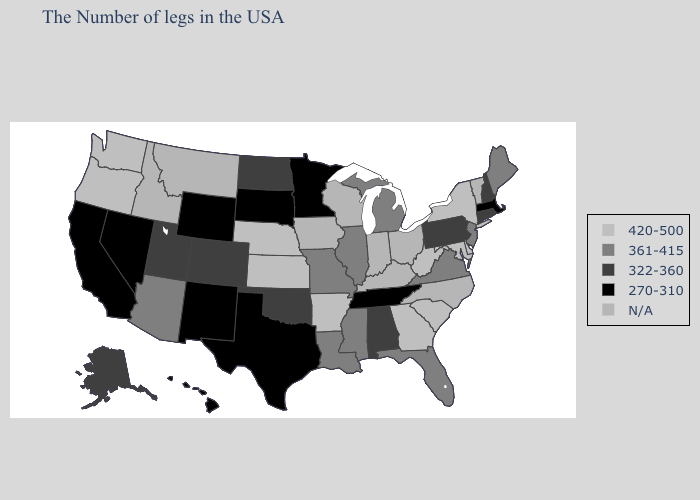Name the states that have a value in the range 420-500?
Answer briefly. New York, Delaware, Maryland, South Carolina, West Virginia, Georgia, Arkansas, Kansas, Nebraska, Washington, Oregon. Name the states that have a value in the range 420-500?
Answer briefly. New York, Delaware, Maryland, South Carolina, West Virginia, Georgia, Arkansas, Kansas, Nebraska, Washington, Oregon. Which states have the lowest value in the USA?
Give a very brief answer. Massachusetts, Tennessee, Minnesota, Texas, South Dakota, Wyoming, New Mexico, Nevada, California, Hawaii. Does Louisiana have the highest value in the South?
Keep it brief. No. What is the highest value in the MidWest ?
Write a very short answer. 420-500. What is the value of South Dakota?
Concise answer only. 270-310. Among the states that border New Hampshire , does Massachusetts have the highest value?
Short answer required. No. What is the value of Kentucky?
Short answer required. N/A. Which states have the lowest value in the USA?
Give a very brief answer. Massachusetts, Tennessee, Minnesota, Texas, South Dakota, Wyoming, New Mexico, Nevada, California, Hawaii. Name the states that have a value in the range 420-500?
Concise answer only. New York, Delaware, Maryland, South Carolina, West Virginia, Georgia, Arkansas, Kansas, Nebraska, Washington, Oregon. Is the legend a continuous bar?
Write a very short answer. No. Among the states that border New Jersey , which have the lowest value?
Quick response, please. Pennsylvania. Name the states that have a value in the range N/A?
Write a very short answer. Vermont, North Carolina, Ohio, Kentucky, Indiana, Wisconsin, Iowa, Montana, Idaho. Name the states that have a value in the range N/A?
Quick response, please. Vermont, North Carolina, Ohio, Kentucky, Indiana, Wisconsin, Iowa, Montana, Idaho. 